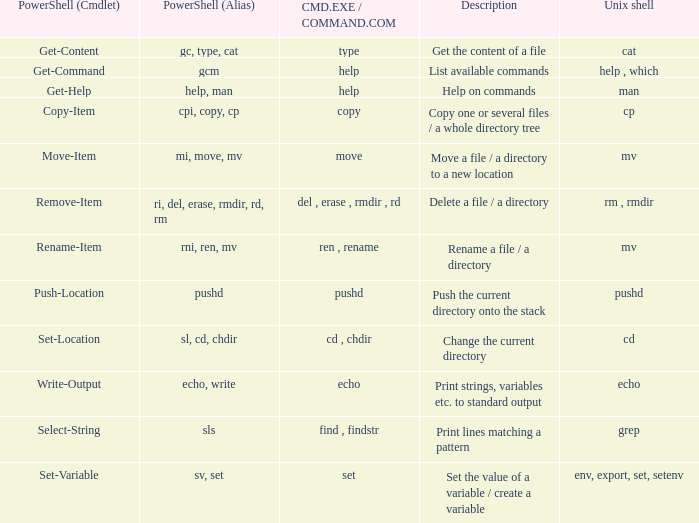Could you help me parse every detail presented in this table? {'header': ['PowerShell (Cmdlet)', 'PowerShell (Alias)', 'CMD.EXE / COMMAND.COM', 'Description', 'Unix shell'], 'rows': [['Get-Content', 'gc, type, cat', 'type', 'Get the content of a file', 'cat'], ['Get-Command', 'gcm', 'help', 'List available commands', 'help , which'], ['Get-Help', 'help, man', 'help', 'Help on commands', 'man'], ['Copy-Item', 'cpi, copy, cp', 'copy', 'Copy one or several files / a whole directory tree', 'cp'], ['Move-Item', 'mi, move, mv', 'move', 'Move a file / a directory to a new location', 'mv'], ['Remove-Item', 'ri, del, erase, rmdir, rd, rm', 'del , erase , rmdir , rd', 'Delete a file / a directory', 'rm , rmdir'], ['Rename-Item', 'rni, ren, mv', 'ren , rename', 'Rename a file / a directory', 'mv'], ['Push-Location', 'pushd', 'pushd', 'Push the current directory onto the stack', 'pushd'], ['Set-Location', 'sl, cd, chdir', 'cd , chdir', 'Change the current directory', 'cd'], ['Write-Output', 'echo, write', 'echo', 'Print strings, variables etc. to standard output', 'echo'], ['Select-String', 'sls', 'find , findstr', 'Print lines matching a pattern', 'grep'], ['Set-Variable', 'sv, set', 'set', 'Set the value of a variable / create a variable', 'env, export, set, setenv']]} When the cmd.exe / command.com is type, what are all associated values for powershell (cmdlet)? Get-Content. 